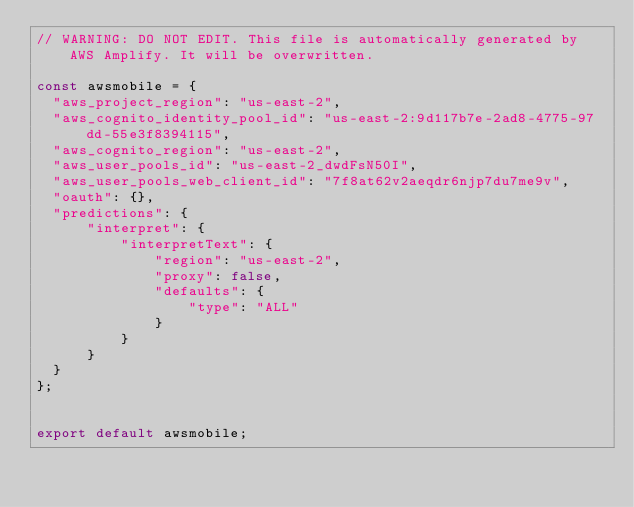Convert code to text. <code><loc_0><loc_0><loc_500><loc_500><_JavaScript_>// WARNING: DO NOT EDIT. This file is automatically generated by AWS Amplify. It will be overwritten.

const awsmobile = {
  "aws_project_region": "us-east-2",
  "aws_cognito_identity_pool_id": "us-east-2:9d117b7e-2ad8-4775-97dd-55e3f8394115",
  "aws_cognito_region": "us-east-2",
  "aws_user_pools_id": "us-east-2_dwdFsN50I",
  "aws_user_pools_web_client_id": "7f8at62v2aeqdr6njp7du7me9v",
  "oauth": {},
  "predictions": {
      "interpret": {
          "interpretText": {
              "region": "us-east-2",
              "proxy": false,
              "defaults": {
                  "type": "ALL"
              }
          }
      }
  }
};


export default awsmobile;
</code> 